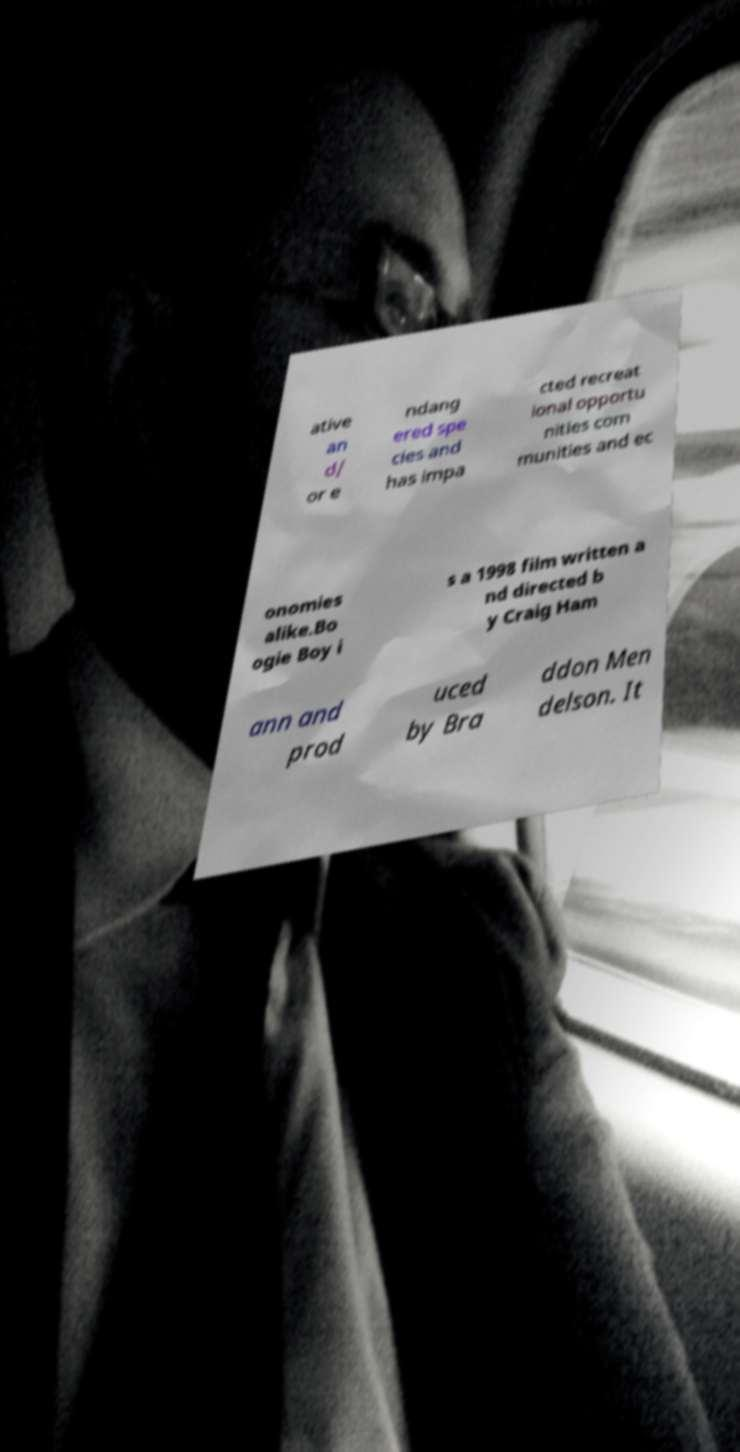Please read and relay the text visible in this image. What does it say? ative an d/ or e ndang ered spe cies and has impa cted recreat ional opportu nities com munities and ec onomies alike.Bo ogie Boy i s a 1998 film written a nd directed b y Craig Ham ann and prod uced by Bra ddon Men delson. It 